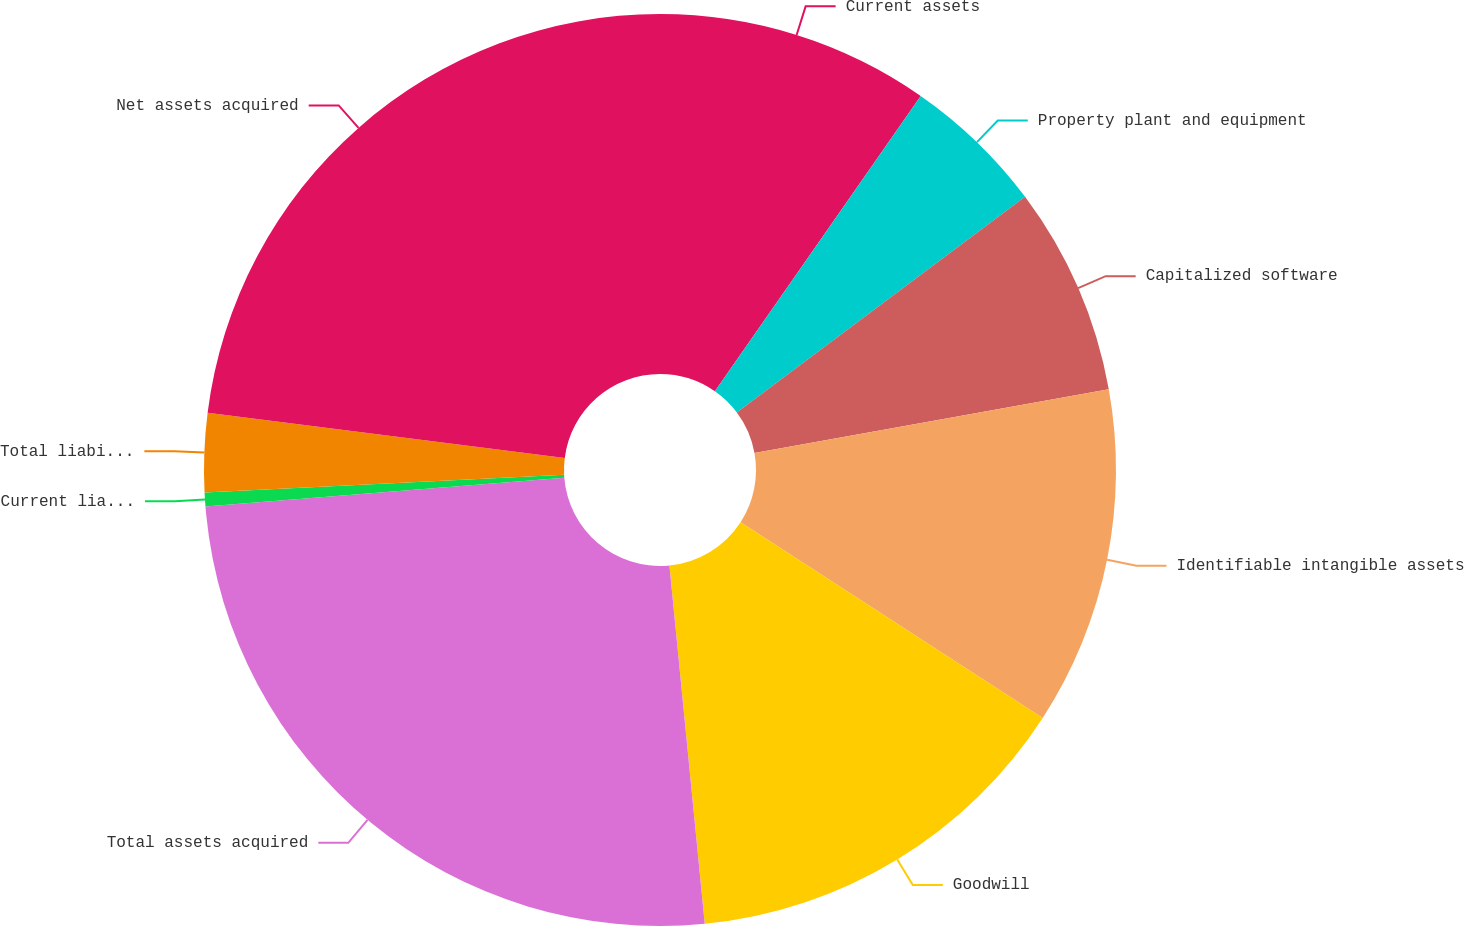Convert chart to OTSL. <chart><loc_0><loc_0><loc_500><loc_500><pie_chart><fcel>Current assets<fcel>Property plant and equipment<fcel>Capitalized software<fcel>Identifiable intangible assets<fcel>Goodwill<fcel>Total assets acquired<fcel>Current liabilities<fcel>Total liabilities assumed<fcel>Net assets acquired<nl><fcel>9.69%<fcel>5.09%<fcel>7.39%<fcel>11.99%<fcel>14.29%<fcel>25.3%<fcel>0.49%<fcel>2.79%<fcel>23.0%<nl></chart> 